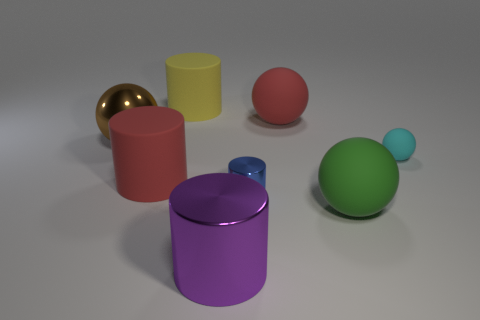Subtract all rubber balls. How many balls are left? 1 Subtract 2 balls. How many balls are left? 2 Add 1 matte things. How many objects exist? 9 Subtract all yellow cylinders. How many cylinders are left? 3 Add 8 tiny cyan balls. How many tiny cyan balls exist? 9 Subtract 0 purple balls. How many objects are left? 8 Subtract all yellow spheres. Subtract all blue blocks. How many spheres are left? 4 Subtract all blue blocks. How many blue balls are left? 0 Subtract all small brown balls. Subtract all yellow matte things. How many objects are left? 7 Add 3 large purple shiny cylinders. How many large purple shiny cylinders are left? 4 